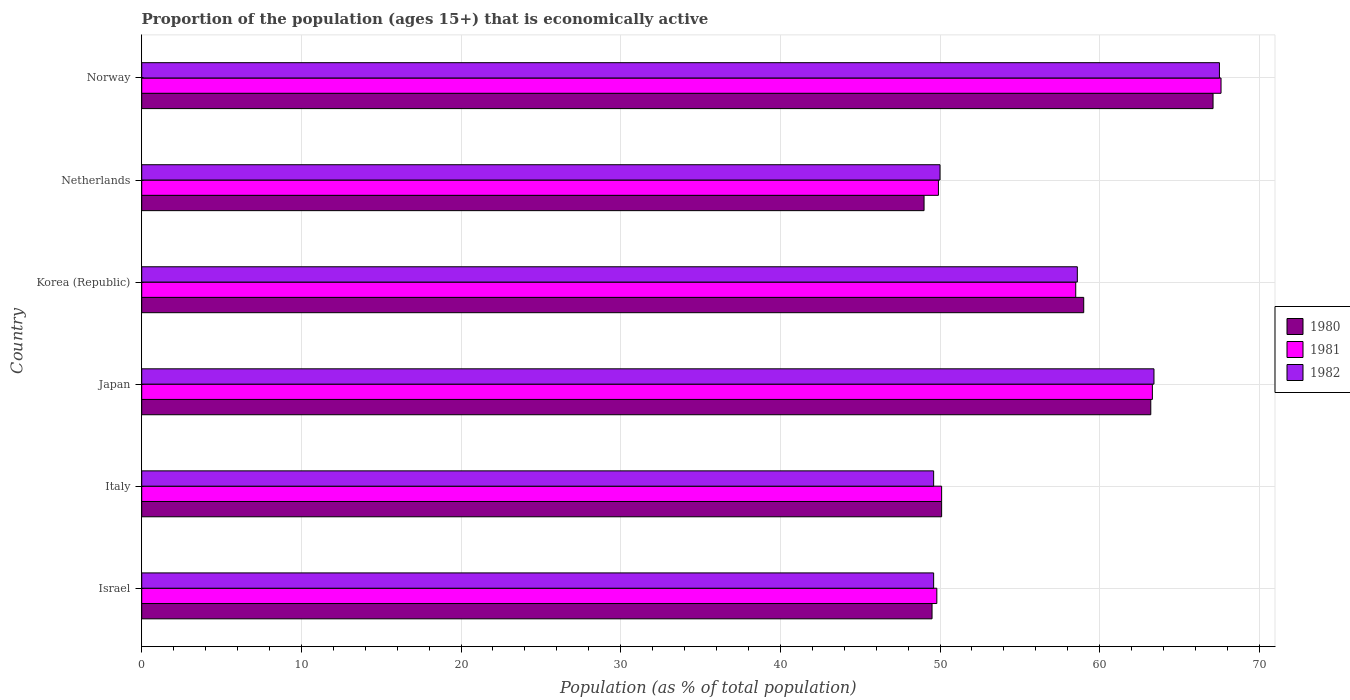Are the number of bars per tick equal to the number of legend labels?
Your answer should be compact. Yes. What is the label of the 5th group of bars from the top?
Your answer should be very brief. Italy. What is the proportion of the population that is economically active in 1981 in Norway?
Offer a very short reply. 67.6. Across all countries, what is the maximum proportion of the population that is economically active in 1980?
Offer a terse response. 67.1. In which country was the proportion of the population that is economically active in 1982 maximum?
Provide a short and direct response. Norway. What is the total proportion of the population that is economically active in 1980 in the graph?
Keep it short and to the point. 337.9. What is the difference between the proportion of the population that is economically active in 1981 in Israel and that in Italy?
Offer a very short reply. -0.3. What is the difference between the proportion of the population that is economically active in 1982 in Italy and the proportion of the population that is economically active in 1980 in Korea (Republic)?
Provide a succinct answer. -9.4. What is the average proportion of the population that is economically active in 1980 per country?
Give a very brief answer. 56.32. What is the difference between the proportion of the population that is economically active in 1982 and proportion of the population that is economically active in 1980 in Netherlands?
Your answer should be compact. 1. In how many countries, is the proportion of the population that is economically active in 1980 greater than 14 %?
Ensure brevity in your answer.  6. What is the ratio of the proportion of the population that is economically active in 1982 in Japan to that in Netherlands?
Provide a succinct answer. 1.27. Is the proportion of the population that is economically active in 1980 in Japan less than that in Korea (Republic)?
Offer a very short reply. No. Is the difference between the proportion of the population that is economically active in 1982 in Korea (Republic) and Norway greater than the difference between the proportion of the population that is economically active in 1980 in Korea (Republic) and Norway?
Keep it short and to the point. No. What is the difference between the highest and the second highest proportion of the population that is economically active in 1982?
Ensure brevity in your answer.  4.1. What is the difference between the highest and the lowest proportion of the population that is economically active in 1982?
Offer a very short reply. 17.9. In how many countries, is the proportion of the population that is economically active in 1980 greater than the average proportion of the population that is economically active in 1980 taken over all countries?
Give a very brief answer. 3. What does the 1st bar from the top in Korea (Republic) represents?
Ensure brevity in your answer.  1982. What does the 1st bar from the bottom in Israel represents?
Keep it short and to the point. 1980. Is it the case that in every country, the sum of the proportion of the population that is economically active in 1980 and proportion of the population that is economically active in 1982 is greater than the proportion of the population that is economically active in 1981?
Offer a very short reply. Yes. How many bars are there?
Provide a short and direct response. 18. What is the difference between two consecutive major ticks on the X-axis?
Your answer should be very brief. 10. Are the values on the major ticks of X-axis written in scientific E-notation?
Make the answer very short. No. Does the graph contain any zero values?
Your response must be concise. No. How many legend labels are there?
Offer a terse response. 3. How are the legend labels stacked?
Make the answer very short. Vertical. What is the title of the graph?
Provide a succinct answer. Proportion of the population (ages 15+) that is economically active. What is the label or title of the X-axis?
Make the answer very short. Population (as % of total population). What is the label or title of the Y-axis?
Make the answer very short. Country. What is the Population (as % of total population) of 1980 in Israel?
Your response must be concise. 49.5. What is the Population (as % of total population) in 1981 in Israel?
Give a very brief answer. 49.8. What is the Population (as % of total population) in 1982 in Israel?
Ensure brevity in your answer.  49.6. What is the Population (as % of total population) of 1980 in Italy?
Give a very brief answer. 50.1. What is the Population (as % of total population) in 1981 in Italy?
Provide a succinct answer. 50.1. What is the Population (as % of total population) of 1982 in Italy?
Provide a succinct answer. 49.6. What is the Population (as % of total population) of 1980 in Japan?
Provide a short and direct response. 63.2. What is the Population (as % of total population) of 1981 in Japan?
Keep it short and to the point. 63.3. What is the Population (as % of total population) in 1982 in Japan?
Give a very brief answer. 63.4. What is the Population (as % of total population) in 1981 in Korea (Republic)?
Provide a short and direct response. 58.5. What is the Population (as % of total population) of 1982 in Korea (Republic)?
Offer a very short reply. 58.6. What is the Population (as % of total population) of 1981 in Netherlands?
Offer a very short reply. 49.9. What is the Population (as % of total population) in 1980 in Norway?
Keep it short and to the point. 67.1. What is the Population (as % of total population) of 1981 in Norway?
Offer a terse response. 67.6. What is the Population (as % of total population) of 1982 in Norway?
Offer a very short reply. 67.5. Across all countries, what is the maximum Population (as % of total population) in 1980?
Give a very brief answer. 67.1. Across all countries, what is the maximum Population (as % of total population) in 1981?
Your response must be concise. 67.6. Across all countries, what is the maximum Population (as % of total population) in 1982?
Provide a succinct answer. 67.5. Across all countries, what is the minimum Population (as % of total population) of 1981?
Keep it short and to the point. 49.8. Across all countries, what is the minimum Population (as % of total population) of 1982?
Provide a succinct answer. 49.6. What is the total Population (as % of total population) in 1980 in the graph?
Offer a very short reply. 337.9. What is the total Population (as % of total population) of 1981 in the graph?
Ensure brevity in your answer.  339.2. What is the total Population (as % of total population) in 1982 in the graph?
Make the answer very short. 338.7. What is the difference between the Population (as % of total population) in 1980 in Israel and that in Italy?
Provide a succinct answer. -0.6. What is the difference between the Population (as % of total population) in 1980 in Israel and that in Japan?
Offer a very short reply. -13.7. What is the difference between the Population (as % of total population) in 1981 in Israel and that in Japan?
Provide a succinct answer. -13.5. What is the difference between the Population (as % of total population) in 1982 in Israel and that in Japan?
Your response must be concise. -13.8. What is the difference between the Population (as % of total population) of 1981 in Israel and that in Korea (Republic)?
Keep it short and to the point. -8.7. What is the difference between the Population (as % of total population) in 1980 in Israel and that in Netherlands?
Your answer should be compact. 0.5. What is the difference between the Population (as % of total population) of 1980 in Israel and that in Norway?
Provide a short and direct response. -17.6. What is the difference between the Population (as % of total population) in 1981 in Israel and that in Norway?
Provide a short and direct response. -17.8. What is the difference between the Population (as % of total population) in 1982 in Israel and that in Norway?
Give a very brief answer. -17.9. What is the difference between the Population (as % of total population) of 1981 in Italy and that in Japan?
Keep it short and to the point. -13.2. What is the difference between the Population (as % of total population) in 1982 in Italy and that in Netherlands?
Your response must be concise. -0.4. What is the difference between the Population (as % of total population) of 1980 in Italy and that in Norway?
Make the answer very short. -17. What is the difference between the Population (as % of total population) of 1981 in Italy and that in Norway?
Your answer should be compact. -17.5. What is the difference between the Population (as % of total population) of 1982 in Italy and that in Norway?
Keep it short and to the point. -17.9. What is the difference between the Population (as % of total population) of 1981 in Japan and that in Korea (Republic)?
Make the answer very short. 4.8. What is the difference between the Population (as % of total population) of 1982 in Japan and that in Korea (Republic)?
Your answer should be very brief. 4.8. What is the difference between the Population (as % of total population) in 1981 in Japan and that in Netherlands?
Make the answer very short. 13.4. What is the difference between the Population (as % of total population) in 1982 in Japan and that in Netherlands?
Give a very brief answer. 13.4. What is the difference between the Population (as % of total population) in 1980 in Japan and that in Norway?
Provide a succinct answer. -3.9. What is the difference between the Population (as % of total population) of 1980 in Korea (Republic) and that in Netherlands?
Give a very brief answer. 10. What is the difference between the Population (as % of total population) of 1981 in Korea (Republic) and that in Netherlands?
Provide a short and direct response. 8.6. What is the difference between the Population (as % of total population) of 1982 in Korea (Republic) and that in Norway?
Give a very brief answer. -8.9. What is the difference between the Population (as % of total population) of 1980 in Netherlands and that in Norway?
Ensure brevity in your answer.  -18.1. What is the difference between the Population (as % of total population) in 1981 in Netherlands and that in Norway?
Ensure brevity in your answer.  -17.7. What is the difference between the Population (as % of total population) in 1982 in Netherlands and that in Norway?
Your answer should be compact. -17.5. What is the difference between the Population (as % of total population) of 1981 in Israel and the Population (as % of total population) of 1982 in Korea (Republic)?
Your answer should be very brief. -8.8. What is the difference between the Population (as % of total population) of 1980 in Israel and the Population (as % of total population) of 1981 in Netherlands?
Ensure brevity in your answer.  -0.4. What is the difference between the Population (as % of total population) in 1980 in Israel and the Population (as % of total population) in 1982 in Netherlands?
Provide a short and direct response. -0.5. What is the difference between the Population (as % of total population) in 1981 in Israel and the Population (as % of total population) in 1982 in Netherlands?
Provide a succinct answer. -0.2. What is the difference between the Population (as % of total population) in 1980 in Israel and the Population (as % of total population) in 1981 in Norway?
Your answer should be compact. -18.1. What is the difference between the Population (as % of total population) of 1980 in Israel and the Population (as % of total population) of 1982 in Norway?
Provide a short and direct response. -18. What is the difference between the Population (as % of total population) of 1981 in Israel and the Population (as % of total population) of 1982 in Norway?
Give a very brief answer. -17.7. What is the difference between the Population (as % of total population) of 1980 in Italy and the Population (as % of total population) of 1982 in Japan?
Ensure brevity in your answer.  -13.3. What is the difference between the Population (as % of total population) in 1980 in Italy and the Population (as % of total population) in 1981 in Netherlands?
Offer a very short reply. 0.2. What is the difference between the Population (as % of total population) in 1980 in Italy and the Population (as % of total population) in 1982 in Netherlands?
Ensure brevity in your answer.  0.1. What is the difference between the Population (as % of total population) of 1981 in Italy and the Population (as % of total population) of 1982 in Netherlands?
Give a very brief answer. 0.1. What is the difference between the Population (as % of total population) in 1980 in Italy and the Population (as % of total population) in 1981 in Norway?
Keep it short and to the point. -17.5. What is the difference between the Population (as % of total population) of 1980 in Italy and the Population (as % of total population) of 1982 in Norway?
Keep it short and to the point. -17.4. What is the difference between the Population (as % of total population) of 1981 in Italy and the Population (as % of total population) of 1982 in Norway?
Ensure brevity in your answer.  -17.4. What is the difference between the Population (as % of total population) in 1980 in Japan and the Population (as % of total population) in 1981 in Netherlands?
Give a very brief answer. 13.3. What is the difference between the Population (as % of total population) of 1980 in Japan and the Population (as % of total population) of 1982 in Netherlands?
Provide a succinct answer. 13.2. What is the difference between the Population (as % of total population) in 1981 in Japan and the Population (as % of total population) in 1982 in Netherlands?
Ensure brevity in your answer.  13.3. What is the difference between the Population (as % of total population) in 1980 in Korea (Republic) and the Population (as % of total population) in 1982 in Netherlands?
Ensure brevity in your answer.  9. What is the difference between the Population (as % of total population) of 1980 in Korea (Republic) and the Population (as % of total population) of 1981 in Norway?
Your answer should be compact. -8.6. What is the difference between the Population (as % of total population) of 1980 in Netherlands and the Population (as % of total population) of 1981 in Norway?
Your answer should be compact. -18.6. What is the difference between the Population (as % of total population) in 1980 in Netherlands and the Population (as % of total population) in 1982 in Norway?
Provide a short and direct response. -18.5. What is the difference between the Population (as % of total population) in 1981 in Netherlands and the Population (as % of total population) in 1982 in Norway?
Ensure brevity in your answer.  -17.6. What is the average Population (as % of total population) in 1980 per country?
Your answer should be compact. 56.32. What is the average Population (as % of total population) of 1981 per country?
Provide a succinct answer. 56.53. What is the average Population (as % of total population) in 1982 per country?
Provide a short and direct response. 56.45. What is the difference between the Population (as % of total population) in 1980 and Population (as % of total population) in 1981 in Israel?
Make the answer very short. -0.3. What is the difference between the Population (as % of total population) in 1980 and Population (as % of total population) in 1982 in Israel?
Offer a terse response. -0.1. What is the difference between the Population (as % of total population) of 1980 and Population (as % of total population) of 1981 in Italy?
Keep it short and to the point. 0. What is the difference between the Population (as % of total population) of 1980 and Population (as % of total population) of 1982 in Italy?
Give a very brief answer. 0.5. What is the difference between the Population (as % of total population) in 1981 and Population (as % of total population) in 1982 in Italy?
Your answer should be compact. 0.5. What is the difference between the Population (as % of total population) of 1980 and Population (as % of total population) of 1982 in Japan?
Your answer should be very brief. -0.2. What is the difference between the Population (as % of total population) in 1980 and Population (as % of total population) in 1981 in Norway?
Provide a succinct answer. -0.5. What is the difference between the Population (as % of total population) in 1980 and Population (as % of total population) in 1982 in Norway?
Your response must be concise. -0.4. What is the difference between the Population (as % of total population) in 1981 and Population (as % of total population) in 1982 in Norway?
Keep it short and to the point. 0.1. What is the ratio of the Population (as % of total population) of 1980 in Israel to that in Italy?
Your response must be concise. 0.99. What is the ratio of the Population (as % of total population) of 1982 in Israel to that in Italy?
Keep it short and to the point. 1. What is the ratio of the Population (as % of total population) in 1980 in Israel to that in Japan?
Your response must be concise. 0.78. What is the ratio of the Population (as % of total population) of 1981 in Israel to that in Japan?
Offer a terse response. 0.79. What is the ratio of the Population (as % of total population) of 1982 in Israel to that in Japan?
Offer a very short reply. 0.78. What is the ratio of the Population (as % of total population) in 1980 in Israel to that in Korea (Republic)?
Keep it short and to the point. 0.84. What is the ratio of the Population (as % of total population) in 1981 in Israel to that in Korea (Republic)?
Your answer should be compact. 0.85. What is the ratio of the Population (as % of total population) of 1982 in Israel to that in Korea (Republic)?
Your answer should be very brief. 0.85. What is the ratio of the Population (as % of total population) of 1980 in Israel to that in Netherlands?
Offer a terse response. 1.01. What is the ratio of the Population (as % of total population) in 1981 in Israel to that in Netherlands?
Offer a terse response. 1. What is the ratio of the Population (as % of total population) in 1982 in Israel to that in Netherlands?
Provide a short and direct response. 0.99. What is the ratio of the Population (as % of total population) of 1980 in Israel to that in Norway?
Provide a succinct answer. 0.74. What is the ratio of the Population (as % of total population) of 1981 in Israel to that in Norway?
Your answer should be compact. 0.74. What is the ratio of the Population (as % of total population) in 1982 in Israel to that in Norway?
Offer a terse response. 0.73. What is the ratio of the Population (as % of total population) in 1980 in Italy to that in Japan?
Offer a very short reply. 0.79. What is the ratio of the Population (as % of total population) of 1981 in Italy to that in Japan?
Give a very brief answer. 0.79. What is the ratio of the Population (as % of total population) of 1982 in Italy to that in Japan?
Give a very brief answer. 0.78. What is the ratio of the Population (as % of total population) of 1980 in Italy to that in Korea (Republic)?
Ensure brevity in your answer.  0.85. What is the ratio of the Population (as % of total population) of 1981 in Italy to that in Korea (Republic)?
Your response must be concise. 0.86. What is the ratio of the Population (as % of total population) of 1982 in Italy to that in Korea (Republic)?
Make the answer very short. 0.85. What is the ratio of the Population (as % of total population) of 1980 in Italy to that in Netherlands?
Your response must be concise. 1.02. What is the ratio of the Population (as % of total population) of 1982 in Italy to that in Netherlands?
Give a very brief answer. 0.99. What is the ratio of the Population (as % of total population) in 1980 in Italy to that in Norway?
Your answer should be compact. 0.75. What is the ratio of the Population (as % of total population) in 1981 in Italy to that in Norway?
Your answer should be compact. 0.74. What is the ratio of the Population (as % of total population) in 1982 in Italy to that in Norway?
Provide a succinct answer. 0.73. What is the ratio of the Population (as % of total population) of 1980 in Japan to that in Korea (Republic)?
Your answer should be compact. 1.07. What is the ratio of the Population (as % of total population) of 1981 in Japan to that in Korea (Republic)?
Provide a short and direct response. 1.08. What is the ratio of the Population (as % of total population) of 1982 in Japan to that in Korea (Republic)?
Provide a succinct answer. 1.08. What is the ratio of the Population (as % of total population) in 1980 in Japan to that in Netherlands?
Make the answer very short. 1.29. What is the ratio of the Population (as % of total population) in 1981 in Japan to that in Netherlands?
Your answer should be very brief. 1.27. What is the ratio of the Population (as % of total population) of 1982 in Japan to that in Netherlands?
Make the answer very short. 1.27. What is the ratio of the Population (as % of total population) of 1980 in Japan to that in Norway?
Keep it short and to the point. 0.94. What is the ratio of the Population (as % of total population) of 1981 in Japan to that in Norway?
Offer a very short reply. 0.94. What is the ratio of the Population (as % of total population) in 1982 in Japan to that in Norway?
Provide a succinct answer. 0.94. What is the ratio of the Population (as % of total population) of 1980 in Korea (Republic) to that in Netherlands?
Make the answer very short. 1.2. What is the ratio of the Population (as % of total population) in 1981 in Korea (Republic) to that in Netherlands?
Your answer should be compact. 1.17. What is the ratio of the Population (as % of total population) in 1982 in Korea (Republic) to that in Netherlands?
Ensure brevity in your answer.  1.17. What is the ratio of the Population (as % of total population) of 1980 in Korea (Republic) to that in Norway?
Make the answer very short. 0.88. What is the ratio of the Population (as % of total population) of 1981 in Korea (Republic) to that in Norway?
Ensure brevity in your answer.  0.87. What is the ratio of the Population (as % of total population) of 1982 in Korea (Republic) to that in Norway?
Provide a succinct answer. 0.87. What is the ratio of the Population (as % of total population) in 1980 in Netherlands to that in Norway?
Your response must be concise. 0.73. What is the ratio of the Population (as % of total population) in 1981 in Netherlands to that in Norway?
Make the answer very short. 0.74. What is the ratio of the Population (as % of total population) of 1982 in Netherlands to that in Norway?
Your answer should be very brief. 0.74. What is the difference between the highest and the second highest Population (as % of total population) of 1981?
Make the answer very short. 4.3. What is the difference between the highest and the lowest Population (as % of total population) in 1980?
Your response must be concise. 18.1. What is the difference between the highest and the lowest Population (as % of total population) in 1981?
Provide a short and direct response. 17.8. What is the difference between the highest and the lowest Population (as % of total population) of 1982?
Provide a succinct answer. 17.9. 